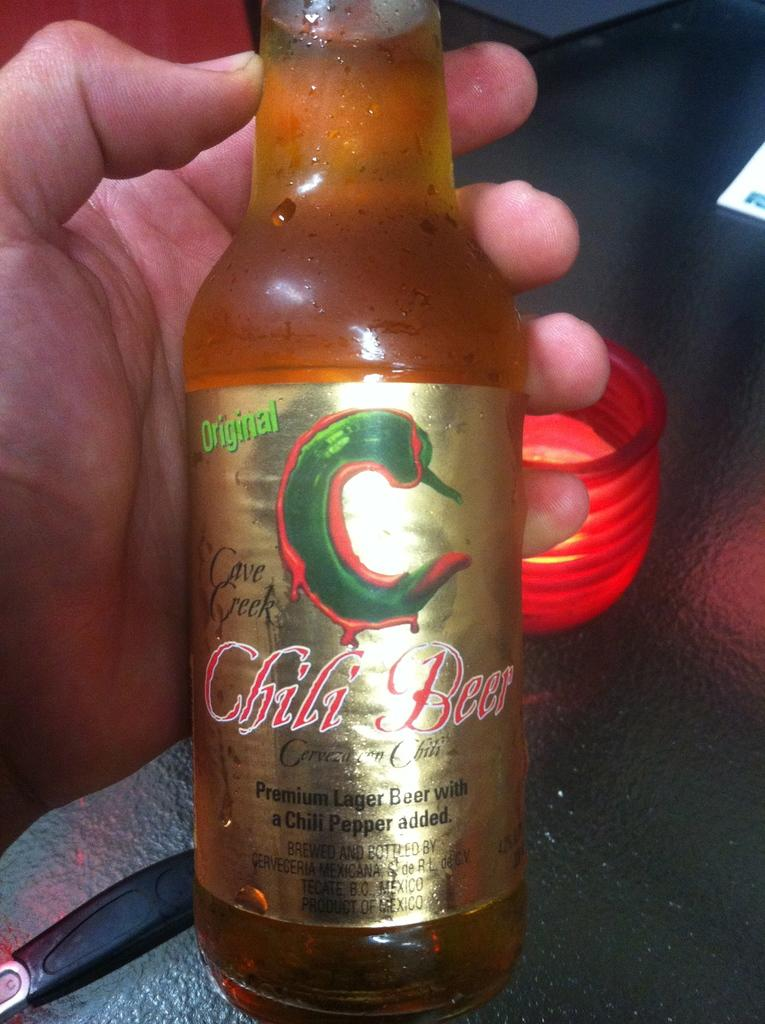What is the person in the image holding? The person is holding a bottle. Can you describe the bottle in more detail? The bottle has a sticker on it and is a container. What is the woman writing on the bottle in the image? There is no woman present in the image, and the bottle does not have any writing on it. 